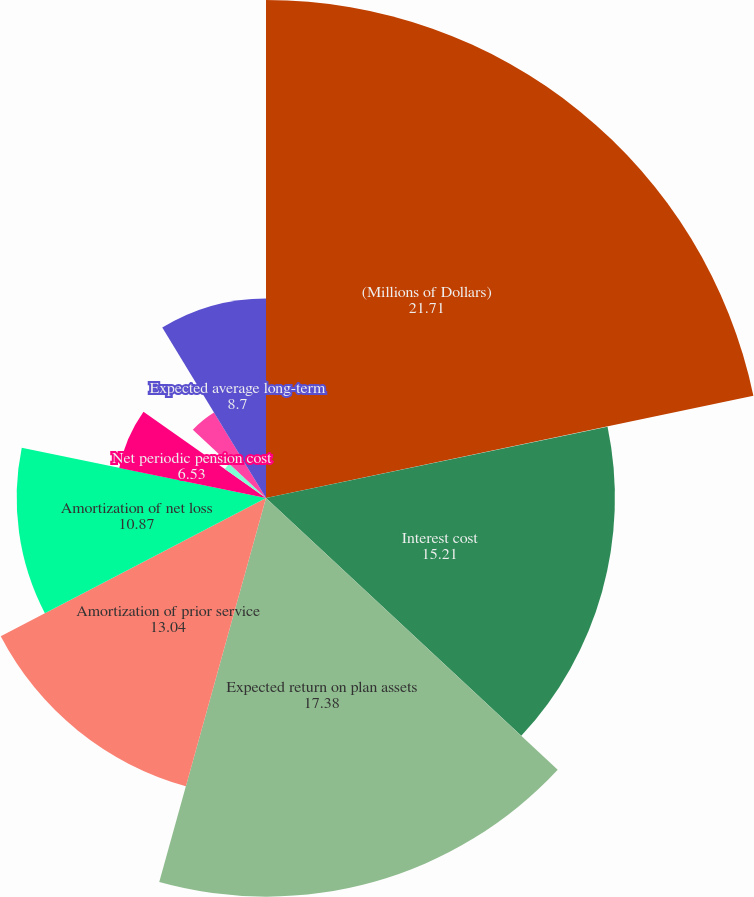Convert chart to OTSL. <chart><loc_0><loc_0><loc_500><loc_500><pie_chart><fcel>(Millions of Dollars)<fcel>Service cost<fcel>Interest cost<fcel>Expected return on plan assets<fcel>Amortization of prior service<fcel>Amortization of net loss<fcel>Net periodic pension cost<fcel>Net benefit cost (credit)<fcel>Discount rate<fcel>Expected average long-term<nl><fcel>21.71%<fcel>0.02%<fcel>15.21%<fcel>17.38%<fcel>13.04%<fcel>10.87%<fcel>6.53%<fcel>2.19%<fcel>4.36%<fcel>8.7%<nl></chart> 